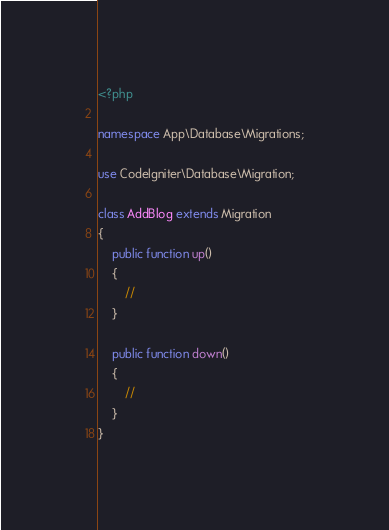<code> <loc_0><loc_0><loc_500><loc_500><_PHP_><?php

namespace App\Database\Migrations;

use CodeIgniter\Database\Migration;

class AddBlog extends Migration
{
	public function up()
	{
		//
	}

	public function down()
	{
		//
	}
}
</code> 